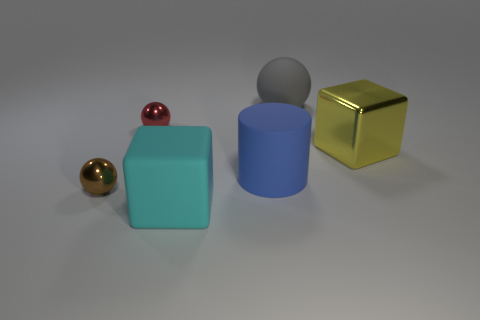What is the small brown sphere made of? Though the image only visually depicts the sphere, the appearance of the small brown sphere suggests it could be a wooden or a plastic ball, as its brown tone and smooth texture are characteristic of such materials. Without additional context or tactile examination, we cannot determine the exact material with certainty. 